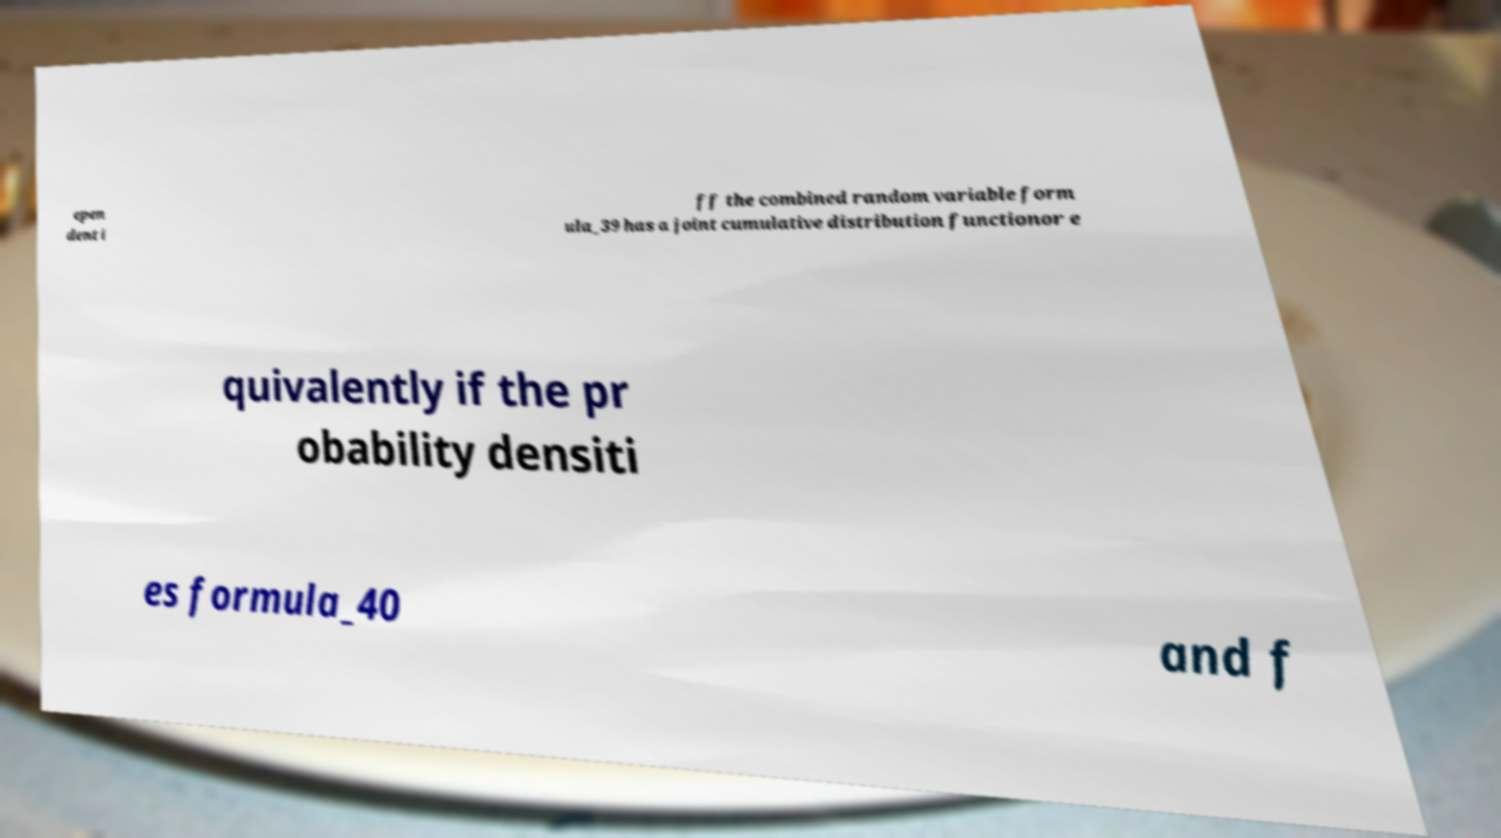Could you assist in decoding the text presented in this image and type it out clearly? epen dent i ff the combined random variable form ula_39 has a joint cumulative distribution functionor e quivalently if the pr obability densiti es formula_40 and f 